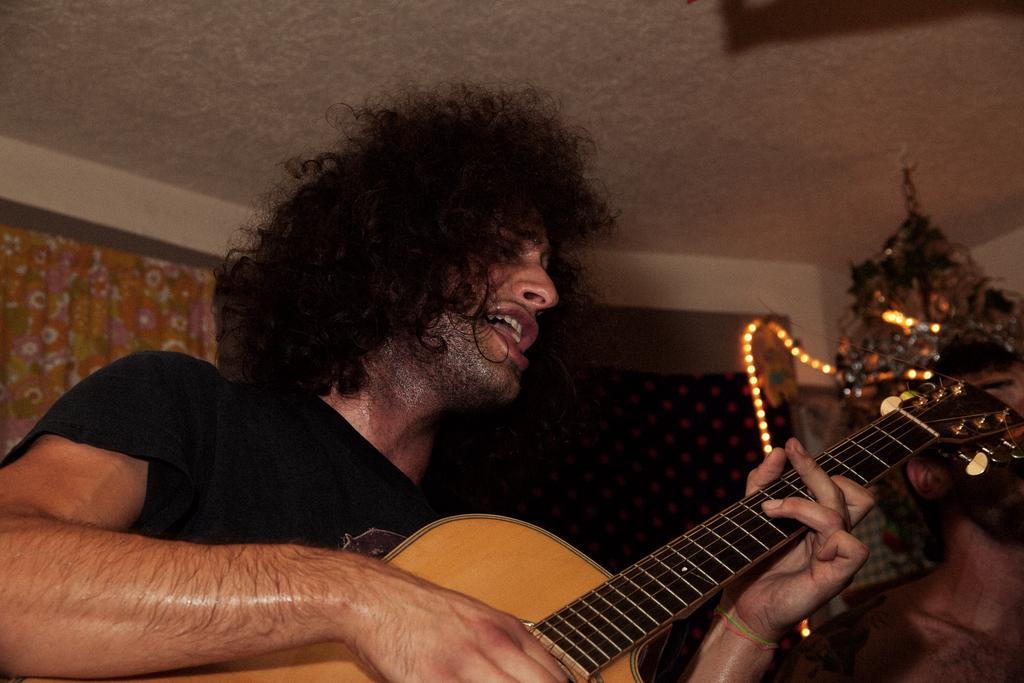Could you give a brief overview of what you see in this image? The image is inside the room. In the image there is a man holding a guitar and opened his mouth for singing. In background there is a curtains, on left side to right side there is a wall which is in white color and roof is on top. 